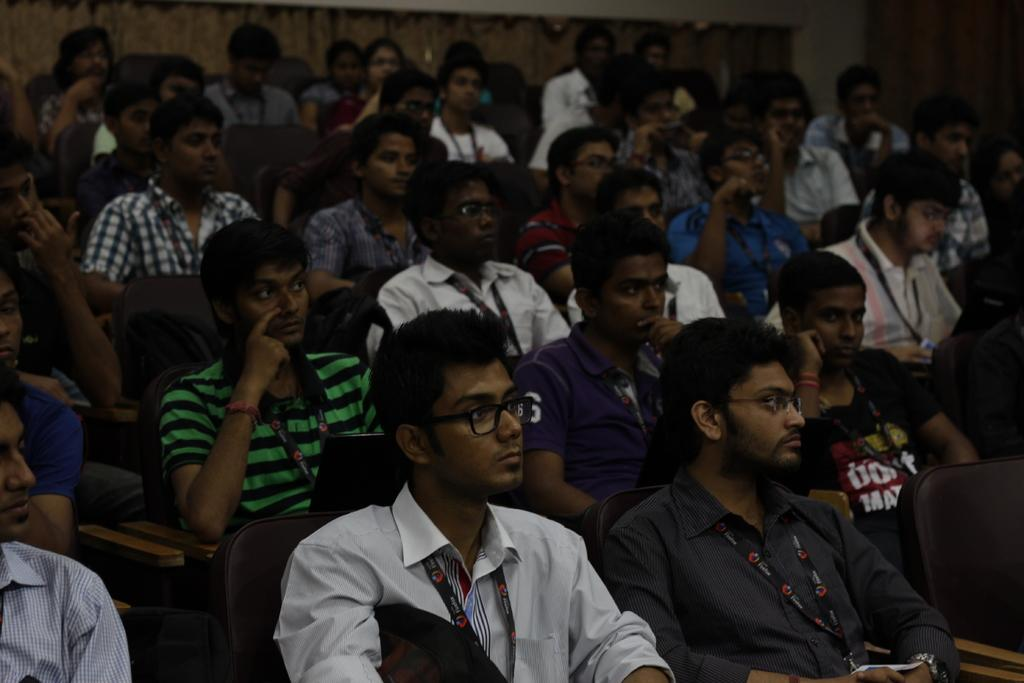What are the people in the image doing? The people in the image are sitting in chairs. What can be seen in the background of the image? There is a wall visible in the background of the image. How many children are playing with the pig in the image? There are no children or pigs present in the image. What type of rhythm can be heard coming from the people in the image? There is no indication of any sound or rhythm in the image, as it only shows people sitting in chairs and a wall in the background. 